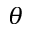Convert formula to latex. <formula><loc_0><loc_0><loc_500><loc_500>\theta</formula> 